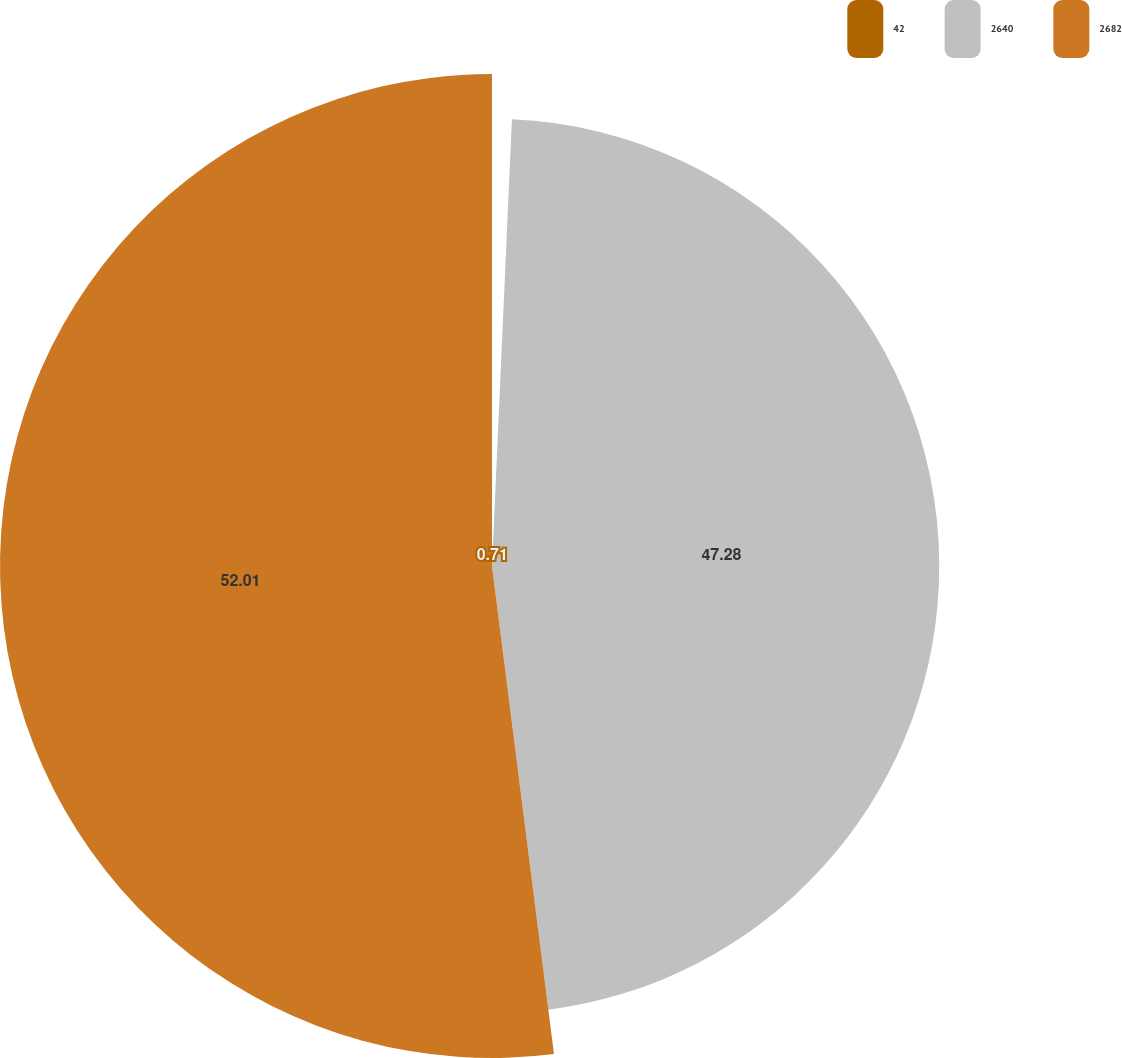Convert chart to OTSL. <chart><loc_0><loc_0><loc_500><loc_500><pie_chart><fcel>42<fcel>2640<fcel>2682<nl><fcel>0.71%<fcel>47.28%<fcel>52.01%<nl></chart> 